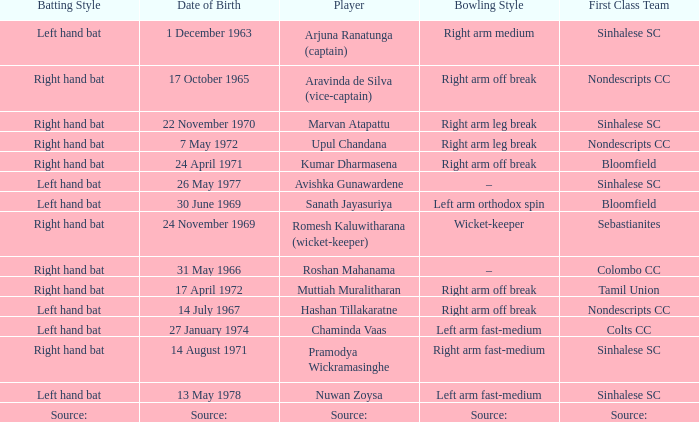When was avishka gunawardene born? 26 May 1977. 